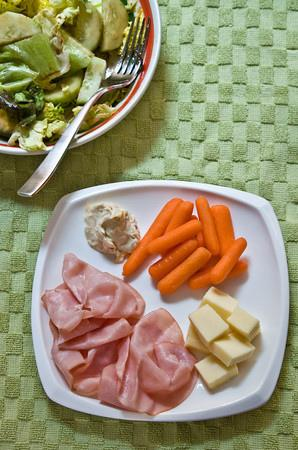Which corner of the plate contains meat? bottom left 